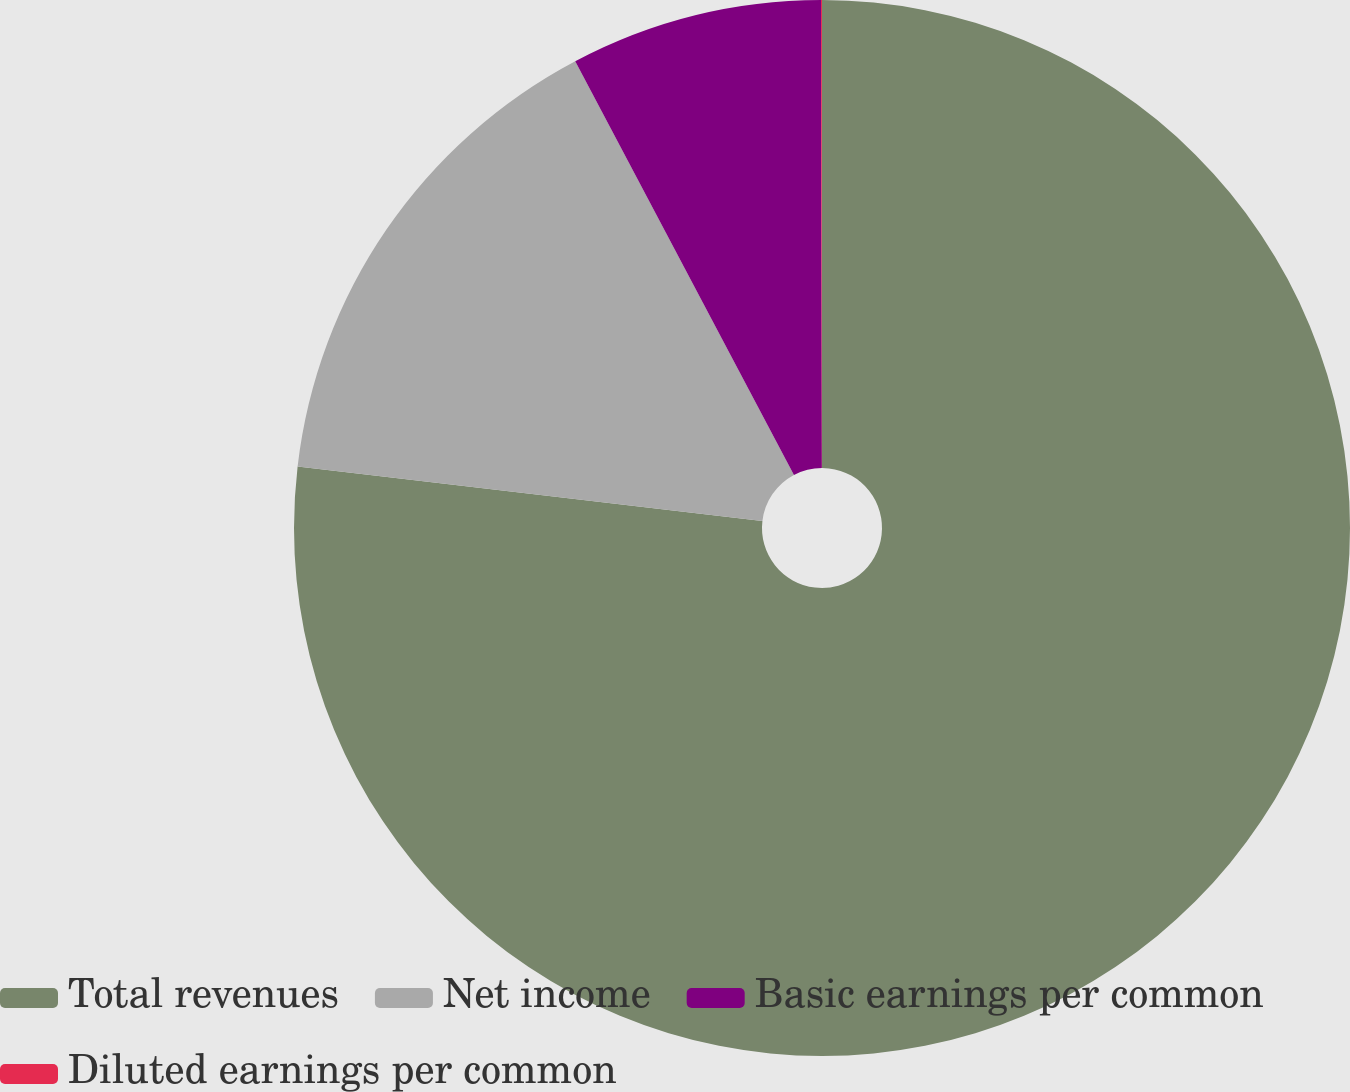<chart> <loc_0><loc_0><loc_500><loc_500><pie_chart><fcel>Total revenues<fcel>Net income<fcel>Basic earnings per common<fcel>Diluted earnings per common<nl><fcel>76.86%<fcel>15.4%<fcel>7.71%<fcel>0.03%<nl></chart> 